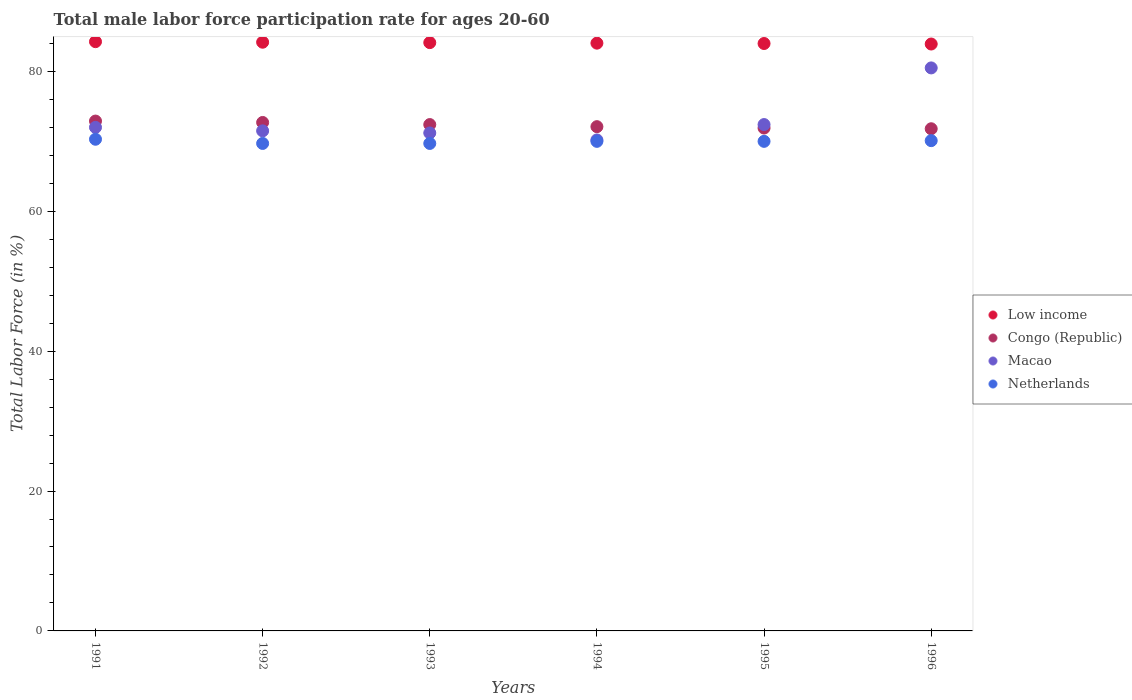How many different coloured dotlines are there?
Offer a very short reply. 4. What is the male labor force participation rate in Congo (Republic) in 1991?
Offer a very short reply. 72.9. Across all years, what is the maximum male labor force participation rate in Macao?
Give a very brief answer. 80.5. Across all years, what is the minimum male labor force participation rate in Netherlands?
Provide a short and direct response. 69.7. What is the total male labor force participation rate in Netherlands in the graph?
Keep it short and to the point. 419.8. What is the difference between the male labor force participation rate in Netherlands in 1993 and that in 1995?
Your answer should be very brief. -0.3. What is the difference between the male labor force participation rate in Netherlands in 1994 and the male labor force participation rate in Macao in 1992?
Your answer should be compact. -1.5. What is the average male labor force participation rate in Low income per year?
Make the answer very short. 84.08. In the year 1995, what is the difference between the male labor force participation rate in Netherlands and male labor force participation rate in Congo (Republic)?
Offer a terse response. -1.9. In how many years, is the male labor force participation rate in Low income greater than 44 %?
Make the answer very short. 6. What is the ratio of the male labor force participation rate in Low income in 1992 to that in 1993?
Your answer should be very brief. 1. Is the male labor force participation rate in Congo (Republic) in 1994 less than that in 1996?
Keep it short and to the point. No. Is the difference between the male labor force participation rate in Netherlands in 1994 and 1995 greater than the difference between the male labor force participation rate in Congo (Republic) in 1994 and 1995?
Your response must be concise. No. What is the difference between the highest and the second highest male labor force participation rate in Low income?
Keep it short and to the point. 0.08. What is the difference between the highest and the lowest male labor force participation rate in Low income?
Give a very brief answer. 0.34. In how many years, is the male labor force participation rate in Macao greater than the average male labor force participation rate in Macao taken over all years?
Offer a very short reply. 1. Is it the case that in every year, the sum of the male labor force participation rate in Netherlands and male labor force participation rate in Low income  is greater than the sum of male labor force participation rate in Congo (Republic) and male labor force participation rate in Macao?
Your response must be concise. Yes. Is it the case that in every year, the sum of the male labor force participation rate in Netherlands and male labor force participation rate in Macao  is greater than the male labor force participation rate in Congo (Republic)?
Your answer should be very brief. Yes. Does the graph contain any zero values?
Your response must be concise. No. What is the title of the graph?
Offer a very short reply. Total male labor force participation rate for ages 20-60. What is the label or title of the X-axis?
Give a very brief answer. Years. What is the label or title of the Y-axis?
Provide a succinct answer. Total Labor Force (in %). What is the Total Labor Force (in %) in Low income in 1991?
Provide a succinct answer. 84.25. What is the Total Labor Force (in %) of Congo (Republic) in 1991?
Give a very brief answer. 72.9. What is the Total Labor Force (in %) in Netherlands in 1991?
Give a very brief answer. 70.3. What is the Total Labor Force (in %) of Low income in 1992?
Provide a short and direct response. 84.17. What is the Total Labor Force (in %) in Congo (Republic) in 1992?
Ensure brevity in your answer.  72.7. What is the Total Labor Force (in %) in Macao in 1992?
Ensure brevity in your answer.  71.5. What is the Total Labor Force (in %) of Netherlands in 1992?
Give a very brief answer. 69.7. What is the Total Labor Force (in %) in Low income in 1993?
Your response must be concise. 84.12. What is the Total Labor Force (in %) of Congo (Republic) in 1993?
Give a very brief answer. 72.4. What is the Total Labor Force (in %) of Macao in 1993?
Your response must be concise. 71.2. What is the Total Labor Force (in %) in Netherlands in 1993?
Keep it short and to the point. 69.7. What is the Total Labor Force (in %) of Low income in 1994?
Provide a short and direct response. 84.04. What is the Total Labor Force (in %) of Congo (Republic) in 1994?
Provide a succinct answer. 72.1. What is the Total Labor Force (in %) of Macao in 1994?
Give a very brief answer. 70.2. What is the Total Labor Force (in %) of Netherlands in 1994?
Your answer should be very brief. 70. What is the Total Labor Force (in %) of Low income in 1995?
Provide a short and direct response. 83.99. What is the Total Labor Force (in %) in Congo (Republic) in 1995?
Make the answer very short. 71.9. What is the Total Labor Force (in %) of Macao in 1995?
Offer a terse response. 72.4. What is the Total Labor Force (in %) of Low income in 1996?
Provide a succinct answer. 83.92. What is the Total Labor Force (in %) of Congo (Republic) in 1996?
Offer a terse response. 71.8. What is the Total Labor Force (in %) of Macao in 1996?
Offer a very short reply. 80.5. What is the Total Labor Force (in %) of Netherlands in 1996?
Offer a terse response. 70.1. Across all years, what is the maximum Total Labor Force (in %) in Low income?
Provide a succinct answer. 84.25. Across all years, what is the maximum Total Labor Force (in %) in Congo (Republic)?
Keep it short and to the point. 72.9. Across all years, what is the maximum Total Labor Force (in %) of Macao?
Give a very brief answer. 80.5. Across all years, what is the maximum Total Labor Force (in %) of Netherlands?
Keep it short and to the point. 70.3. Across all years, what is the minimum Total Labor Force (in %) in Low income?
Provide a succinct answer. 83.92. Across all years, what is the minimum Total Labor Force (in %) in Congo (Republic)?
Ensure brevity in your answer.  71.8. Across all years, what is the minimum Total Labor Force (in %) of Macao?
Your answer should be very brief. 70.2. Across all years, what is the minimum Total Labor Force (in %) in Netherlands?
Ensure brevity in your answer.  69.7. What is the total Total Labor Force (in %) of Low income in the graph?
Provide a succinct answer. 504.49. What is the total Total Labor Force (in %) in Congo (Republic) in the graph?
Ensure brevity in your answer.  433.8. What is the total Total Labor Force (in %) in Macao in the graph?
Provide a succinct answer. 437.8. What is the total Total Labor Force (in %) in Netherlands in the graph?
Your answer should be compact. 419.8. What is the difference between the Total Labor Force (in %) of Low income in 1991 and that in 1992?
Provide a succinct answer. 0.08. What is the difference between the Total Labor Force (in %) of Macao in 1991 and that in 1992?
Offer a terse response. 0.5. What is the difference between the Total Labor Force (in %) of Netherlands in 1991 and that in 1992?
Provide a succinct answer. 0.6. What is the difference between the Total Labor Force (in %) of Low income in 1991 and that in 1993?
Offer a terse response. 0.14. What is the difference between the Total Labor Force (in %) of Macao in 1991 and that in 1993?
Your response must be concise. 0.8. What is the difference between the Total Labor Force (in %) of Netherlands in 1991 and that in 1993?
Your answer should be compact. 0.6. What is the difference between the Total Labor Force (in %) in Low income in 1991 and that in 1994?
Offer a very short reply. 0.21. What is the difference between the Total Labor Force (in %) of Congo (Republic) in 1991 and that in 1994?
Your response must be concise. 0.8. What is the difference between the Total Labor Force (in %) of Macao in 1991 and that in 1994?
Make the answer very short. 1.8. What is the difference between the Total Labor Force (in %) of Low income in 1991 and that in 1995?
Your answer should be compact. 0.26. What is the difference between the Total Labor Force (in %) in Congo (Republic) in 1991 and that in 1995?
Provide a short and direct response. 1. What is the difference between the Total Labor Force (in %) in Low income in 1991 and that in 1996?
Make the answer very short. 0.34. What is the difference between the Total Labor Force (in %) of Netherlands in 1991 and that in 1996?
Ensure brevity in your answer.  0.2. What is the difference between the Total Labor Force (in %) of Low income in 1992 and that in 1993?
Your response must be concise. 0.06. What is the difference between the Total Labor Force (in %) in Netherlands in 1992 and that in 1993?
Your answer should be compact. 0. What is the difference between the Total Labor Force (in %) in Low income in 1992 and that in 1994?
Provide a short and direct response. 0.13. What is the difference between the Total Labor Force (in %) of Congo (Republic) in 1992 and that in 1994?
Offer a terse response. 0.6. What is the difference between the Total Labor Force (in %) of Low income in 1992 and that in 1995?
Offer a very short reply. 0.18. What is the difference between the Total Labor Force (in %) of Congo (Republic) in 1992 and that in 1995?
Provide a succinct answer. 0.8. What is the difference between the Total Labor Force (in %) of Macao in 1992 and that in 1995?
Provide a succinct answer. -0.9. What is the difference between the Total Labor Force (in %) in Netherlands in 1992 and that in 1995?
Your answer should be very brief. -0.3. What is the difference between the Total Labor Force (in %) of Low income in 1992 and that in 1996?
Provide a short and direct response. 0.26. What is the difference between the Total Labor Force (in %) in Congo (Republic) in 1992 and that in 1996?
Offer a terse response. 0.9. What is the difference between the Total Labor Force (in %) of Low income in 1993 and that in 1994?
Ensure brevity in your answer.  0.08. What is the difference between the Total Labor Force (in %) of Low income in 1993 and that in 1995?
Give a very brief answer. 0.13. What is the difference between the Total Labor Force (in %) in Macao in 1993 and that in 1995?
Provide a succinct answer. -1.2. What is the difference between the Total Labor Force (in %) of Low income in 1993 and that in 1996?
Keep it short and to the point. 0.2. What is the difference between the Total Labor Force (in %) in Netherlands in 1993 and that in 1996?
Your response must be concise. -0.4. What is the difference between the Total Labor Force (in %) of Low income in 1994 and that in 1995?
Offer a very short reply. 0.05. What is the difference between the Total Labor Force (in %) in Netherlands in 1994 and that in 1995?
Offer a terse response. 0. What is the difference between the Total Labor Force (in %) in Low income in 1994 and that in 1996?
Offer a terse response. 0.12. What is the difference between the Total Labor Force (in %) of Congo (Republic) in 1994 and that in 1996?
Provide a succinct answer. 0.3. What is the difference between the Total Labor Force (in %) in Macao in 1994 and that in 1996?
Your answer should be very brief. -10.3. What is the difference between the Total Labor Force (in %) in Netherlands in 1994 and that in 1996?
Ensure brevity in your answer.  -0.1. What is the difference between the Total Labor Force (in %) in Low income in 1995 and that in 1996?
Your answer should be very brief. 0.07. What is the difference between the Total Labor Force (in %) in Netherlands in 1995 and that in 1996?
Offer a very short reply. -0.1. What is the difference between the Total Labor Force (in %) in Low income in 1991 and the Total Labor Force (in %) in Congo (Republic) in 1992?
Provide a succinct answer. 11.55. What is the difference between the Total Labor Force (in %) in Low income in 1991 and the Total Labor Force (in %) in Macao in 1992?
Ensure brevity in your answer.  12.75. What is the difference between the Total Labor Force (in %) in Low income in 1991 and the Total Labor Force (in %) in Netherlands in 1992?
Your response must be concise. 14.55. What is the difference between the Total Labor Force (in %) in Congo (Republic) in 1991 and the Total Labor Force (in %) in Netherlands in 1992?
Provide a succinct answer. 3.2. What is the difference between the Total Labor Force (in %) of Macao in 1991 and the Total Labor Force (in %) of Netherlands in 1992?
Your answer should be compact. 2.3. What is the difference between the Total Labor Force (in %) of Low income in 1991 and the Total Labor Force (in %) of Congo (Republic) in 1993?
Ensure brevity in your answer.  11.85. What is the difference between the Total Labor Force (in %) of Low income in 1991 and the Total Labor Force (in %) of Macao in 1993?
Offer a very short reply. 13.05. What is the difference between the Total Labor Force (in %) of Low income in 1991 and the Total Labor Force (in %) of Netherlands in 1993?
Give a very brief answer. 14.55. What is the difference between the Total Labor Force (in %) of Congo (Republic) in 1991 and the Total Labor Force (in %) of Netherlands in 1993?
Keep it short and to the point. 3.2. What is the difference between the Total Labor Force (in %) in Low income in 1991 and the Total Labor Force (in %) in Congo (Republic) in 1994?
Your response must be concise. 12.15. What is the difference between the Total Labor Force (in %) of Low income in 1991 and the Total Labor Force (in %) of Macao in 1994?
Your answer should be compact. 14.05. What is the difference between the Total Labor Force (in %) of Low income in 1991 and the Total Labor Force (in %) of Netherlands in 1994?
Keep it short and to the point. 14.25. What is the difference between the Total Labor Force (in %) of Low income in 1991 and the Total Labor Force (in %) of Congo (Republic) in 1995?
Offer a terse response. 12.35. What is the difference between the Total Labor Force (in %) of Low income in 1991 and the Total Labor Force (in %) of Macao in 1995?
Make the answer very short. 11.85. What is the difference between the Total Labor Force (in %) of Low income in 1991 and the Total Labor Force (in %) of Netherlands in 1995?
Offer a terse response. 14.25. What is the difference between the Total Labor Force (in %) of Congo (Republic) in 1991 and the Total Labor Force (in %) of Netherlands in 1995?
Provide a succinct answer. 2.9. What is the difference between the Total Labor Force (in %) in Low income in 1991 and the Total Labor Force (in %) in Congo (Republic) in 1996?
Your answer should be compact. 12.45. What is the difference between the Total Labor Force (in %) in Low income in 1991 and the Total Labor Force (in %) in Macao in 1996?
Your response must be concise. 3.75. What is the difference between the Total Labor Force (in %) in Low income in 1991 and the Total Labor Force (in %) in Netherlands in 1996?
Give a very brief answer. 14.15. What is the difference between the Total Labor Force (in %) of Congo (Republic) in 1991 and the Total Labor Force (in %) of Netherlands in 1996?
Offer a very short reply. 2.8. What is the difference between the Total Labor Force (in %) of Macao in 1991 and the Total Labor Force (in %) of Netherlands in 1996?
Ensure brevity in your answer.  1.9. What is the difference between the Total Labor Force (in %) of Low income in 1992 and the Total Labor Force (in %) of Congo (Republic) in 1993?
Provide a succinct answer. 11.77. What is the difference between the Total Labor Force (in %) in Low income in 1992 and the Total Labor Force (in %) in Macao in 1993?
Make the answer very short. 12.97. What is the difference between the Total Labor Force (in %) of Low income in 1992 and the Total Labor Force (in %) of Netherlands in 1993?
Your answer should be very brief. 14.47. What is the difference between the Total Labor Force (in %) in Congo (Republic) in 1992 and the Total Labor Force (in %) in Macao in 1993?
Provide a short and direct response. 1.5. What is the difference between the Total Labor Force (in %) of Congo (Republic) in 1992 and the Total Labor Force (in %) of Netherlands in 1993?
Your answer should be compact. 3. What is the difference between the Total Labor Force (in %) in Macao in 1992 and the Total Labor Force (in %) in Netherlands in 1993?
Provide a succinct answer. 1.8. What is the difference between the Total Labor Force (in %) of Low income in 1992 and the Total Labor Force (in %) of Congo (Republic) in 1994?
Give a very brief answer. 12.07. What is the difference between the Total Labor Force (in %) in Low income in 1992 and the Total Labor Force (in %) in Macao in 1994?
Provide a short and direct response. 13.97. What is the difference between the Total Labor Force (in %) of Low income in 1992 and the Total Labor Force (in %) of Netherlands in 1994?
Keep it short and to the point. 14.17. What is the difference between the Total Labor Force (in %) in Low income in 1992 and the Total Labor Force (in %) in Congo (Republic) in 1995?
Provide a short and direct response. 12.27. What is the difference between the Total Labor Force (in %) of Low income in 1992 and the Total Labor Force (in %) of Macao in 1995?
Provide a succinct answer. 11.77. What is the difference between the Total Labor Force (in %) of Low income in 1992 and the Total Labor Force (in %) of Netherlands in 1995?
Offer a very short reply. 14.17. What is the difference between the Total Labor Force (in %) in Congo (Republic) in 1992 and the Total Labor Force (in %) in Netherlands in 1995?
Make the answer very short. 2.7. What is the difference between the Total Labor Force (in %) of Macao in 1992 and the Total Labor Force (in %) of Netherlands in 1995?
Offer a very short reply. 1.5. What is the difference between the Total Labor Force (in %) of Low income in 1992 and the Total Labor Force (in %) of Congo (Republic) in 1996?
Your response must be concise. 12.37. What is the difference between the Total Labor Force (in %) in Low income in 1992 and the Total Labor Force (in %) in Macao in 1996?
Provide a short and direct response. 3.67. What is the difference between the Total Labor Force (in %) in Low income in 1992 and the Total Labor Force (in %) in Netherlands in 1996?
Your answer should be very brief. 14.07. What is the difference between the Total Labor Force (in %) in Macao in 1992 and the Total Labor Force (in %) in Netherlands in 1996?
Ensure brevity in your answer.  1.4. What is the difference between the Total Labor Force (in %) in Low income in 1993 and the Total Labor Force (in %) in Congo (Republic) in 1994?
Provide a short and direct response. 12.02. What is the difference between the Total Labor Force (in %) of Low income in 1993 and the Total Labor Force (in %) of Macao in 1994?
Your answer should be compact. 13.92. What is the difference between the Total Labor Force (in %) in Low income in 1993 and the Total Labor Force (in %) in Netherlands in 1994?
Offer a terse response. 14.12. What is the difference between the Total Labor Force (in %) in Congo (Republic) in 1993 and the Total Labor Force (in %) in Macao in 1994?
Provide a succinct answer. 2.2. What is the difference between the Total Labor Force (in %) in Congo (Republic) in 1993 and the Total Labor Force (in %) in Netherlands in 1994?
Give a very brief answer. 2.4. What is the difference between the Total Labor Force (in %) of Low income in 1993 and the Total Labor Force (in %) of Congo (Republic) in 1995?
Make the answer very short. 12.22. What is the difference between the Total Labor Force (in %) in Low income in 1993 and the Total Labor Force (in %) in Macao in 1995?
Your answer should be very brief. 11.72. What is the difference between the Total Labor Force (in %) of Low income in 1993 and the Total Labor Force (in %) of Netherlands in 1995?
Provide a succinct answer. 14.12. What is the difference between the Total Labor Force (in %) in Congo (Republic) in 1993 and the Total Labor Force (in %) in Netherlands in 1995?
Your answer should be very brief. 2.4. What is the difference between the Total Labor Force (in %) of Low income in 1993 and the Total Labor Force (in %) of Congo (Republic) in 1996?
Offer a terse response. 12.32. What is the difference between the Total Labor Force (in %) of Low income in 1993 and the Total Labor Force (in %) of Macao in 1996?
Offer a very short reply. 3.62. What is the difference between the Total Labor Force (in %) of Low income in 1993 and the Total Labor Force (in %) of Netherlands in 1996?
Give a very brief answer. 14.02. What is the difference between the Total Labor Force (in %) of Congo (Republic) in 1993 and the Total Labor Force (in %) of Macao in 1996?
Give a very brief answer. -8.1. What is the difference between the Total Labor Force (in %) in Congo (Republic) in 1993 and the Total Labor Force (in %) in Netherlands in 1996?
Offer a very short reply. 2.3. What is the difference between the Total Labor Force (in %) of Low income in 1994 and the Total Labor Force (in %) of Congo (Republic) in 1995?
Keep it short and to the point. 12.14. What is the difference between the Total Labor Force (in %) in Low income in 1994 and the Total Labor Force (in %) in Macao in 1995?
Your response must be concise. 11.64. What is the difference between the Total Labor Force (in %) in Low income in 1994 and the Total Labor Force (in %) in Netherlands in 1995?
Ensure brevity in your answer.  14.04. What is the difference between the Total Labor Force (in %) of Macao in 1994 and the Total Labor Force (in %) of Netherlands in 1995?
Your answer should be compact. 0.2. What is the difference between the Total Labor Force (in %) of Low income in 1994 and the Total Labor Force (in %) of Congo (Republic) in 1996?
Offer a very short reply. 12.24. What is the difference between the Total Labor Force (in %) in Low income in 1994 and the Total Labor Force (in %) in Macao in 1996?
Ensure brevity in your answer.  3.54. What is the difference between the Total Labor Force (in %) of Low income in 1994 and the Total Labor Force (in %) of Netherlands in 1996?
Your answer should be very brief. 13.94. What is the difference between the Total Labor Force (in %) of Low income in 1995 and the Total Labor Force (in %) of Congo (Republic) in 1996?
Your response must be concise. 12.19. What is the difference between the Total Labor Force (in %) of Low income in 1995 and the Total Labor Force (in %) of Macao in 1996?
Keep it short and to the point. 3.49. What is the difference between the Total Labor Force (in %) of Low income in 1995 and the Total Labor Force (in %) of Netherlands in 1996?
Make the answer very short. 13.89. What is the difference between the Total Labor Force (in %) of Congo (Republic) in 1995 and the Total Labor Force (in %) of Netherlands in 1996?
Offer a terse response. 1.8. What is the difference between the Total Labor Force (in %) of Macao in 1995 and the Total Labor Force (in %) of Netherlands in 1996?
Offer a very short reply. 2.3. What is the average Total Labor Force (in %) in Low income per year?
Your answer should be very brief. 84.08. What is the average Total Labor Force (in %) in Congo (Republic) per year?
Make the answer very short. 72.3. What is the average Total Labor Force (in %) of Macao per year?
Ensure brevity in your answer.  72.97. What is the average Total Labor Force (in %) in Netherlands per year?
Your response must be concise. 69.97. In the year 1991, what is the difference between the Total Labor Force (in %) of Low income and Total Labor Force (in %) of Congo (Republic)?
Give a very brief answer. 11.35. In the year 1991, what is the difference between the Total Labor Force (in %) in Low income and Total Labor Force (in %) in Macao?
Keep it short and to the point. 12.25. In the year 1991, what is the difference between the Total Labor Force (in %) in Low income and Total Labor Force (in %) in Netherlands?
Give a very brief answer. 13.95. In the year 1992, what is the difference between the Total Labor Force (in %) in Low income and Total Labor Force (in %) in Congo (Republic)?
Provide a succinct answer. 11.47. In the year 1992, what is the difference between the Total Labor Force (in %) of Low income and Total Labor Force (in %) of Macao?
Provide a succinct answer. 12.67. In the year 1992, what is the difference between the Total Labor Force (in %) in Low income and Total Labor Force (in %) in Netherlands?
Offer a very short reply. 14.47. In the year 1992, what is the difference between the Total Labor Force (in %) of Congo (Republic) and Total Labor Force (in %) of Netherlands?
Your answer should be compact. 3. In the year 1993, what is the difference between the Total Labor Force (in %) in Low income and Total Labor Force (in %) in Congo (Republic)?
Offer a very short reply. 11.72. In the year 1993, what is the difference between the Total Labor Force (in %) of Low income and Total Labor Force (in %) of Macao?
Give a very brief answer. 12.92. In the year 1993, what is the difference between the Total Labor Force (in %) of Low income and Total Labor Force (in %) of Netherlands?
Your answer should be very brief. 14.42. In the year 1993, what is the difference between the Total Labor Force (in %) of Congo (Republic) and Total Labor Force (in %) of Macao?
Your answer should be very brief. 1.2. In the year 1994, what is the difference between the Total Labor Force (in %) of Low income and Total Labor Force (in %) of Congo (Republic)?
Give a very brief answer. 11.94. In the year 1994, what is the difference between the Total Labor Force (in %) of Low income and Total Labor Force (in %) of Macao?
Your answer should be very brief. 13.84. In the year 1994, what is the difference between the Total Labor Force (in %) of Low income and Total Labor Force (in %) of Netherlands?
Offer a very short reply. 14.04. In the year 1994, what is the difference between the Total Labor Force (in %) in Congo (Republic) and Total Labor Force (in %) in Macao?
Ensure brevity in your answer.  1.9. In the year 1995, what is the difference between the Total Labor Force (in %) of Low income and Total Labor Force (in %) of Congo (Republic)?
Give a very brief answer. 12.09. In the year 1995, what is the difference between the Total Labor Force (in %) of Low income and Total Labor Force (in %) of Macao?
Provide a short and direct response. 11.59. In the year 1995, what is the difference between the Total Labor Force (in %) of Low income and Total Labor Force (in %) of Netherlands?
Offer a very short reply. 13.99. In the year 1995, what is the difference between the Total Labor Force (in %) of Congo (Republic) and Total Labor Force (in %) of Macao?
Offer a very short reply. -0.5. In the year 1996, what is the difference between the Total Labor Force (in %) of Low income and Total Labor Force (in %) of Congo (Republic)?
Provide a short and direct response. 12.12. In the year 1996, what is the difference between the Total Labor Force (in %) of Low income and Total Labor Force (in %) of Macao?
Your answer should be compact. 3.42. In the year 1996, what is the difference between the Total Labor Force (in %) in Low income and Total Labor Force (in %) in Netherlands?
Offer a very short reply. 13.82. In the year 1996, what is the difference between the Total Labor Force (in %) of Congo (Republic) and Total Labor Force (in %) of Macao?
Your answer should be very brief. -8.7. What is the ratio of the Total Labor Force (in %) of Macao in 1991 to that in 1992?
Your answer should be very brief. 1.01. What is the ratio of the Total Labor Force (in %) of Netherlands in 1991 to that in 1992?
Keep it short and to the point. 1.01. What is the ratio of the Total Labor Force (in %) in Low income in 1991 to that in 1993?
Make the answer very short. 1. What is the ratio of the Total Labor Force (in %) in Congo (Republic) in 1991 to that in 1993?
Provide a succinct answer. 1.01. What is the ratio of the Total Labor Force (in %) in Macao in 1991 to that in 1993?
Your response must be concise. 1.01. What is the ratio of the Total Labor Force (in %) of Netherlands in 1991 to that in 1993?
Your response must be concise. 1.01. What is the ratio of the Total Labor Force (in %) in Low income in 1991 to that in 1994?
Ensure brevity in your answer.  1. What is the ratio of the Total Labor Force (in %) in Congo (Republic) in 1991 to that in 1994?
Give a very brief answer. 1.01. What is the ratio of the Total Labor Force (in %) in Macao in 1991 to that in 1994?
Make the answer very short. 1.03. What is the ratio of the Total Labor Force (in %) in Netherlands in 1991 to that in 1994?
Offer a terse response. 1. What is the ratio of the Total Labor Force (in %) in Low income in 1991 to that in 1995?
Your answer should be very brief. 1. What is the ratio of the Total Labor Force (in %) in Congo (Republic) in 1991 to that in 1995?
Offer a terse response. 1.01. What is the ratio of the Total Labor Force (in %) in Macao in 1991 to that in 1995?
Offer a very short reply. 0.99. What is the ratio of the Total Labor Force (in %) of Low income in 1991 to that in 1996?
Your answer should be very brief. 1. What is the ratio of the Total Labor Force (in %) in Congo (Republic) in 1991 to that in 1996?
Ensure brevity in your answer.  1.02. What is the ratio of the Total Labor Force (in %) of Macao in 1991 to that in 1996?
Provide a succinct answer. 0.89. What is the ratio of the Total Labor Force (in %) of Netherlands in 1991 to that in 1996?
Give a very brief answer. 1. What is the ratio of the Total Labor Force (in %) in Low income in 1992 to that in 1993?
Give a very brief answer. 1. What is the ratio of the Total Labor Force (in %) of Congo (Republic) in 1992 to that in 1993?
Give a very brief answer. 1. What is the ratio of the Total Labor Force (in %) in Netherlands in 1992 to that in 1993?
Your answer should be very brief. 1. What is the ratio of the Total Labor Force (in %) of Congo (Republic) in 1992 to that in 1994?
Ensure brevity in your answer.  1.01. What is the ratio of the Total Labor Force (in %) of Macao in 1992 to that in 1994?
Offer a terse response. 1.02. What is the ratio of the Total Labor Force (in %) of Congo (Republic) in 1992 to that in 1995?
Ensure brevity in your answer.  1.01. What is the ratio of the Total Labor Force (in %) of Macao in 1992 to that in 1995?
Keep it short and to the point. 0.99. What is the ratio of the Total Labor Force (in %) in Congo (Republic) in 1992 to that in 1996?
Keep it short and to the point. 1.01. What is the ratio of the Total Labor Force (in %) of Macao in 1992 to that in 1996?
Your answer should be very brief. 0.89. What is the ratio of the Total Labor Force (in %) in Low income in 1993 to that in 1994?
Your answer should be compact. 1. What is the ratio of the Total Labor Force (in %) of Congo (Republic) in 1993 to that in 1994?
Offer a very short reply. 1. What is the ratio of the Total Labor Force (in %) in Macao in 1993 to that in 1994?
Make the answer very short. 1.01. What is the ratio of the Total Labor Force (in %) of Netherlands in 1993 to that in 1994?
Give a very brief answer. 1. What is the ratio of the Total Labor Force (in %) in Congo (Republic) in 1993 to that in 1995?
Keep it short and to the point. 1.01. What is the ratio of the Total Labor Force (in %) of Macao in 1993 to that in 1995?
Provide a short and direct response. 0.98. What is the ratio of the Total Labor Force (in %) in Netherlands in 1993 to that in 1995?
Provide a succinct answer. 1. What is the ratio of the Total Labor Force (in %) of Congo (Republic) in 1993 to that in 1996?
Your answer should be compact. 1.01. What is the ratio of the Total Labor Force (in %) of Macao in 1993 to that in 1996?
Make the answer very short. 0.88. What is the ratio of the Total Labor Force (in %) in Congo (Republic) in 1994 to that in 1995?
Ensure brevity in your answer.  1. What is the ratio of the Total Labor Force (in %) in Macao in 1994 to that in 1995?
Your answer should be compact. 0.97. What is the ratio of the Total Labor Force (in %) in Low income in 1994 to that in 1996?
Ensure brevity in your answer.  1. What is the ratio of the Total Labor Force (in %) in Macao in 1994 to that in 1996?
Your answer should be very brief. 0.87. What is the ratio of the Total Labor Force (in %) of Low income in 1995 to that in 1996?
Ensure brevity in your answer.  1. What is the ratio of the Total Labor Force (in %) of Congo (Republic) in 1995 to that in 1996?
Your answer should be compact. 1. What is the ratio of the Total Labor Force (in %) of Macao in 1995 to that in 1996?
Provide a succinct answer. 0.9. What is the ratio of the Total Labor Force (in %) in Netherlands in 1995 to that in 1996?
Provide a short and direct response. 1. What is the difference between the highest and the second highest Total Labor Force (in %) in Low income?
Give a very brief answer. 0.08. What is the difference between the highest and the second highest Total Labor Force (in %) in Netherlands?
Offer a terse response. 0.2. What is the difference between the highest and the lowest Total Labor Force (in %) in Low income?
Keep it short and to the point. 0.34. What is the difference between the highest and the lowest Total Labor Force (in %) in Macao?
Your response must be concise. 10.3. 